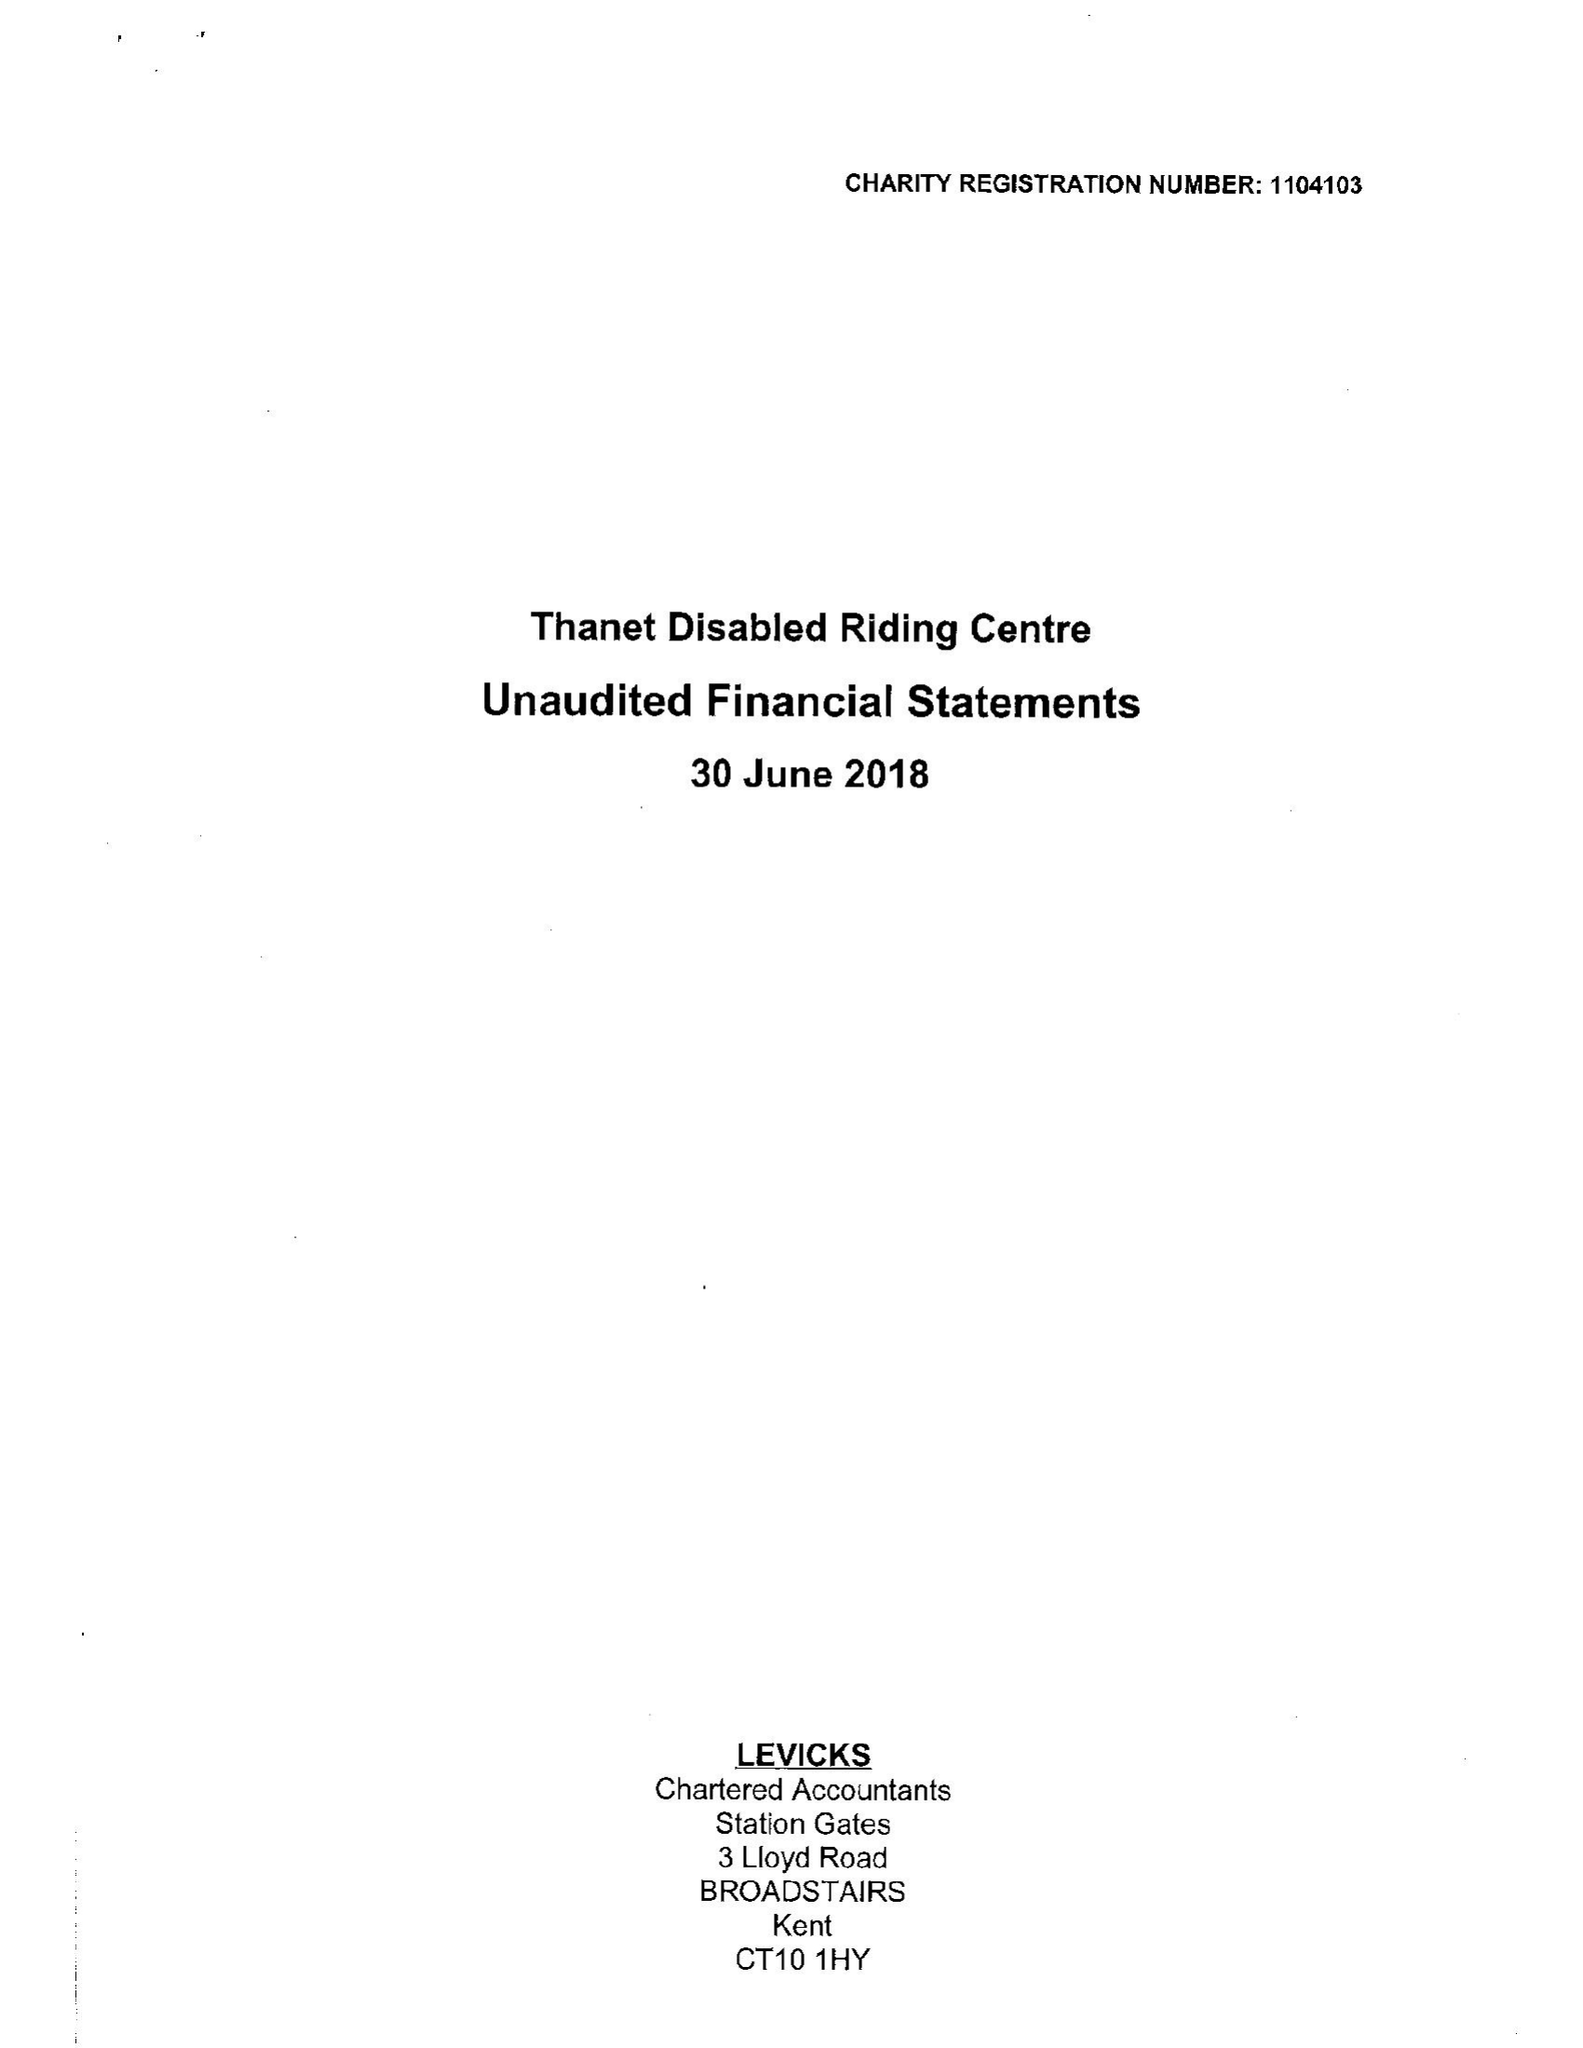What is the value for the charity_number?
Answer the question using a single word or phrase. 1104103 